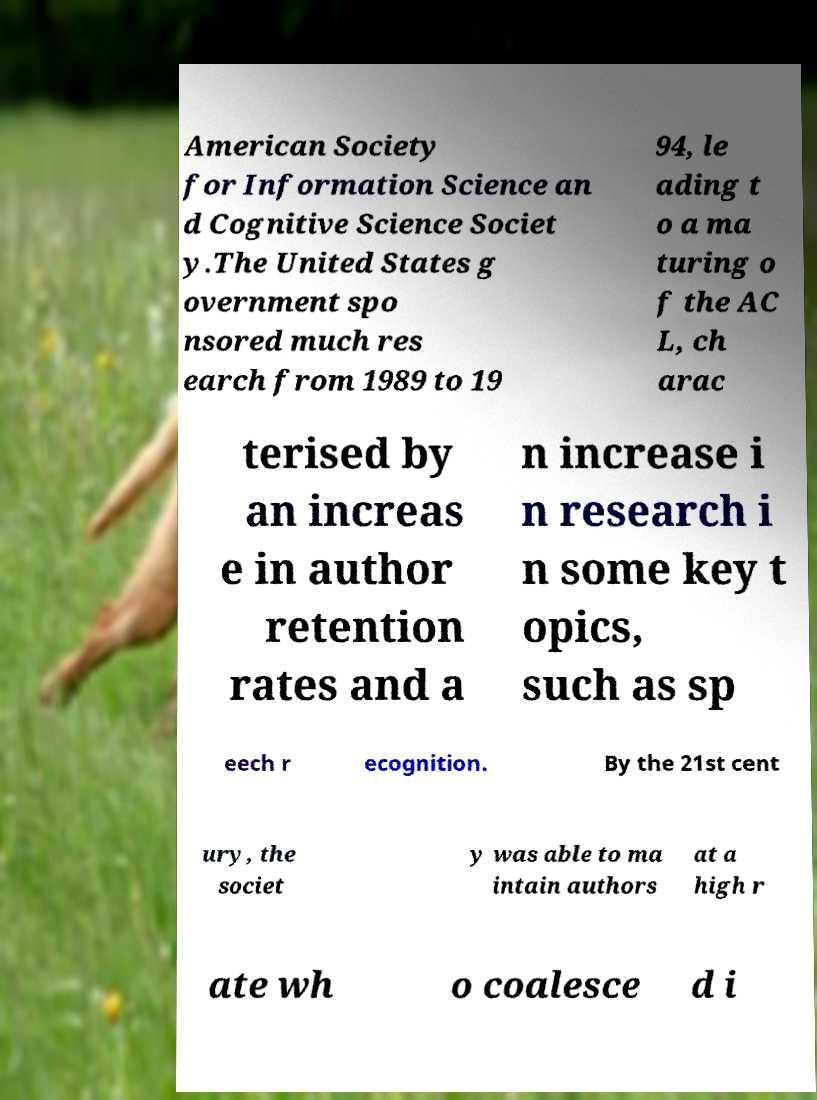There's text embedded in this image that I need extracted. Can you transcribe it verbatim? American Society for Information Science an d Cognitive Science Societ y.The United States g overnment spo nsored much res earch from 1989 to 19 94, le ading t o a ma turing o f the AC L, ch arac terised by an increas e in author retention rates and a n increase i n research i n some key t opics, such as sp eech r ecognition. By the 21st cent ury, the societ y was able to ma intain authors at a high r ate wh o coalesce d i 